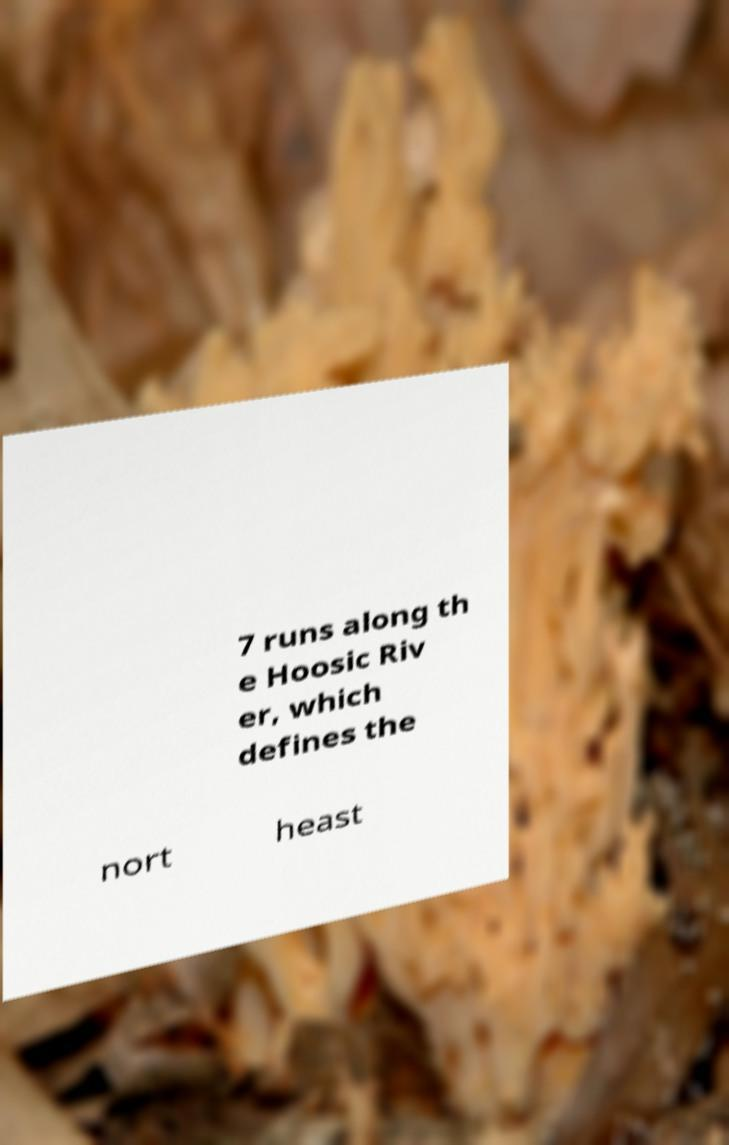What messages or text are displayed in this image? I need them in a readable, typed format. 7 runs along th e Hoosic Riv er, which defines the nort heast 